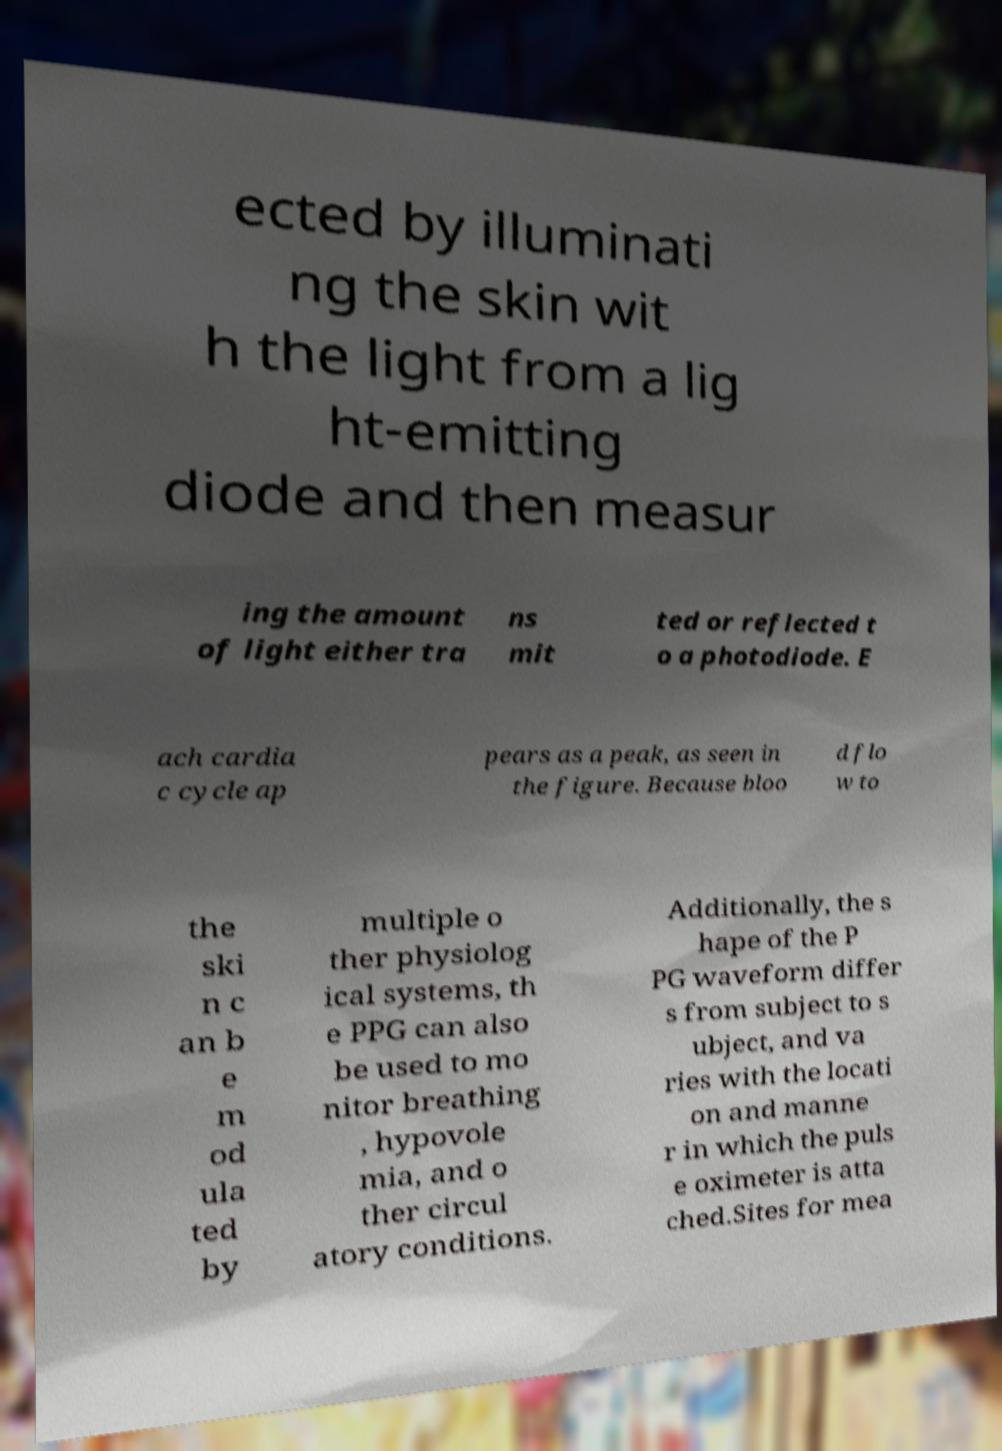Could you assist in decoding the text presented in this image and type it out clearly? ected by illuminati ng the skin wit h the light from a lig ht-emitting diode and then measur ing the amount of light either tra ns mit ted or reflected t o a photodiode. E ach cardia c cycle ap pears as a peak, as seen in the figure. Because bloo d flo w to the ski n c an b e m od ula ted by multiple o ther physiolog ical systems, th e PPG can also be used to mo nitor breathing , hypovole mia, and o ther circul atory conditions. Additionally, the s hape of the P PG waveform differ s from subject to s ubject, and va ries with the locati on and manne r in which the puls e oximeter is atta ched.Sites for mea 